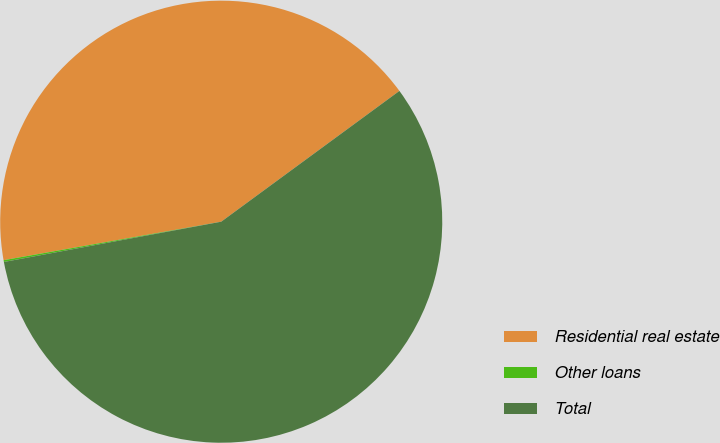Convert chart to OTSL. <chart><loc_0><loc_0><loc_500><loc_500><pie_chart><fcel>Residential real estate<fcel>Other loans<fcel>Total<nl><fcel>42.71%<fcel>0.13%<fcel>57.16%<nl></chart> 